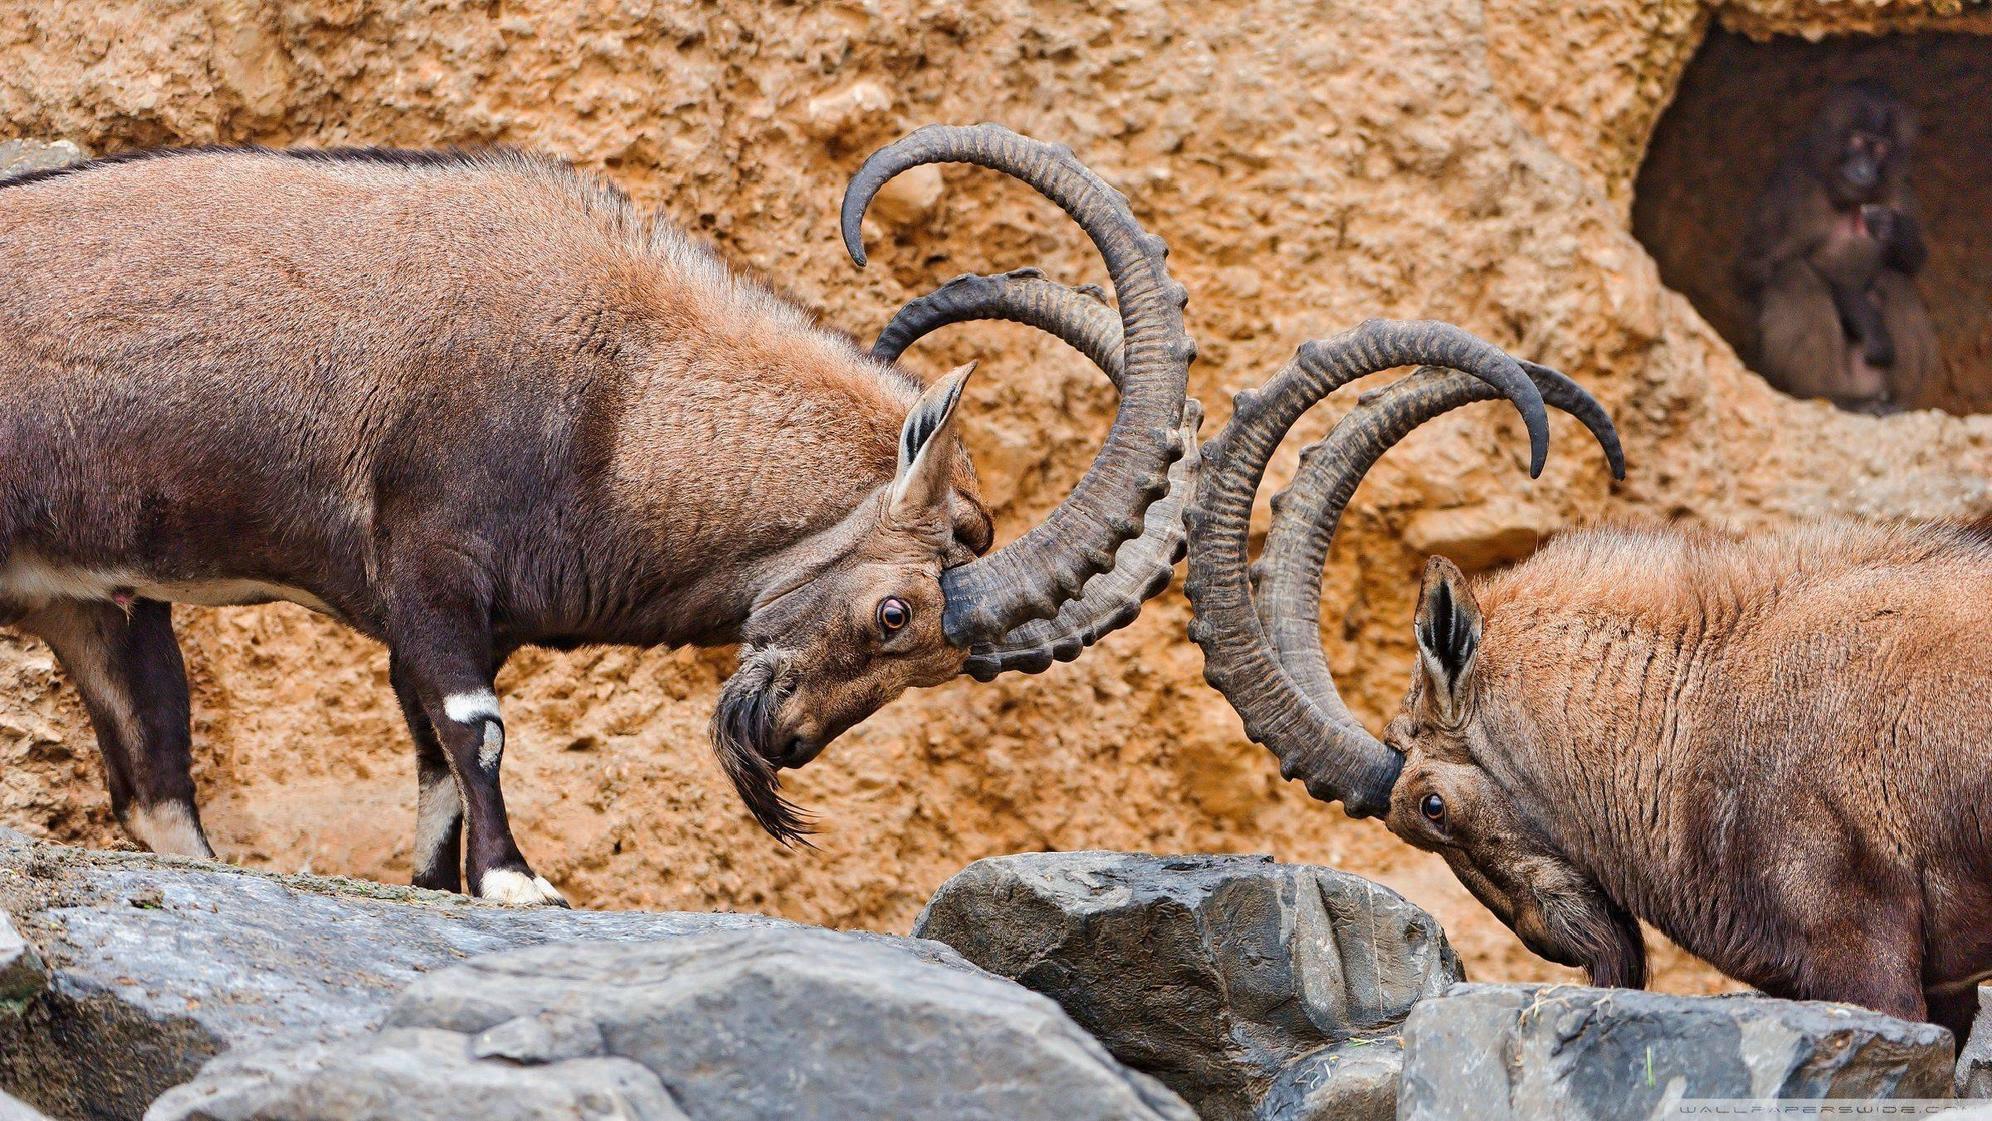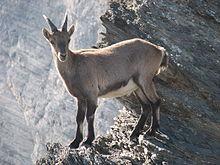The first image is the image on the left, the second image is the image on the right. Considering the images on both sides, is "the sky is visible in the image on the right" valid? Answer yes or no. No. The first image is the image on the left, the second image is the image on the right. Evaluate the accuracy of this statement regarding the images: "There are at least two goats and none of them are on the grass.". Is it true? Answer yes or no. Yes. 